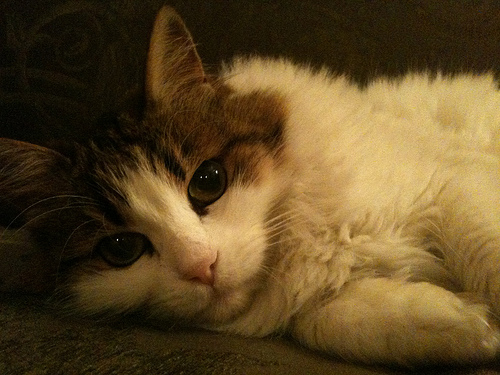<image>
Is there a cat above the rug? No. The cat is not positioned above the rug. The vertical arrangement shows a different relationship. 